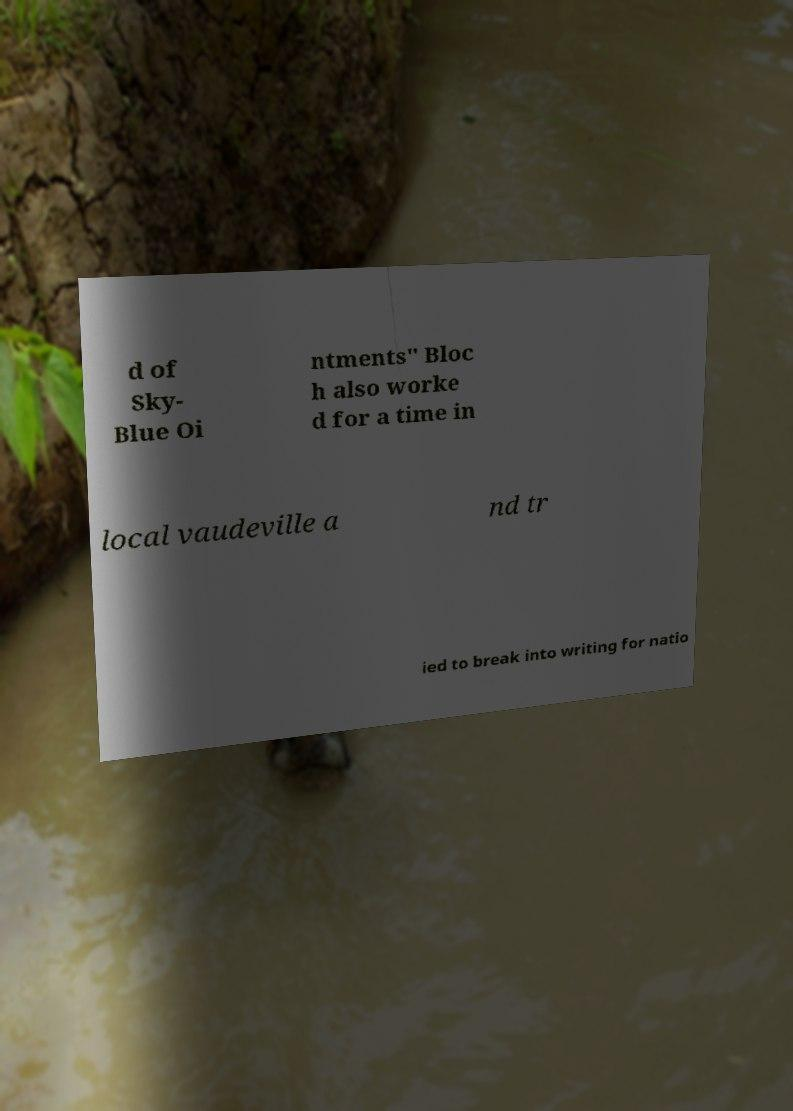I need the written content from this picture converted into text. Can you do that? d of Sky- Blue Oi ntments" Bloc h also worke d for a time in local vaudeville a nd tr ied to break into writing for natio 